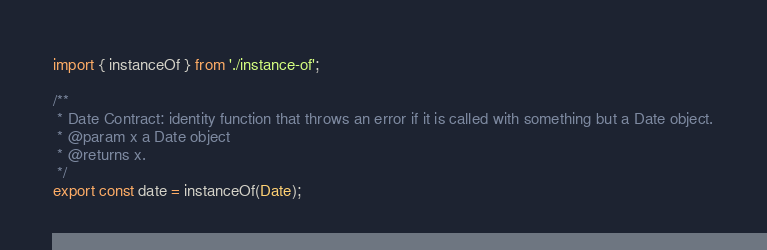Convert code to text. <code><loc_0><loc_0><loc_500><loc_500><_TypeScript_>import { instanceOf } from './instance-of';

/**
 * Date Contract: identity function that throws an error if it is called with something but a Date object.
 * @param x a Date object
 * @returns x.
 */
export const date = instanceOf(Date);
</code> 